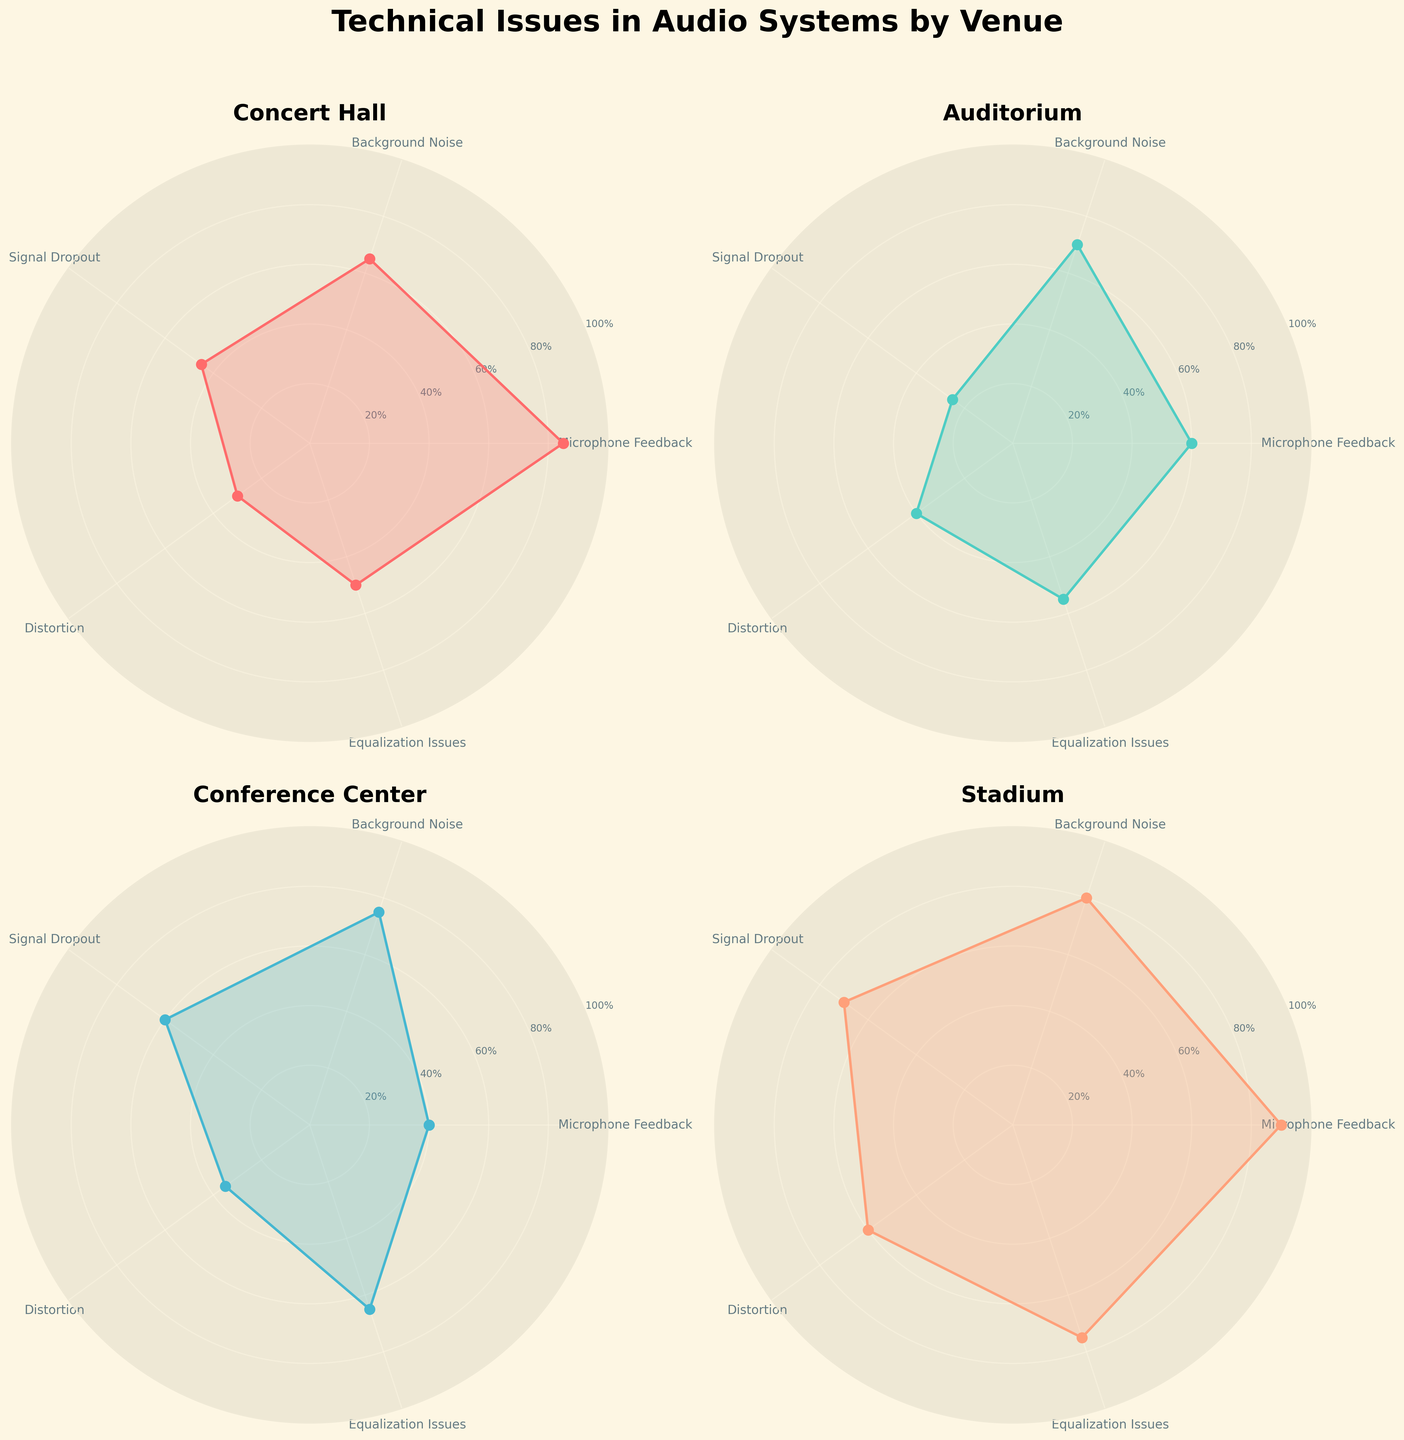What is the most frequent technical issue in Stadiums? Look at the Stadium subplot and identify the highest point on the radar chart. The highest value is for Background Noise at 80.
Answer: Background Noise Which venue reports the highest frequency of Microphone Feedback? Compare the Microphone Feedback frequencies across all four subplots. The highest value is in the Stadium subplot at 90.
Answer: Stadium How does the frequency of Signal Dropout in Conference Centers compare to that in Concert Halls? Find the values for Signal Dropout in both venues. In the Conference Center, it's 60; in the Concert Hall, it's 45.
Answer: Higher in Conference Centers Which technical issue has the lowest frequency in the Auditorium? Identify the lowest point on the radar chart for the Auditorium subplot. The lowest value is for Signal Dropout at 25.
Answer: Signal Dropout What is the average frequency of technical issues in Concert Halls? Sum the frequencies of all issues in Concert Halls and divide by the number of issues. (85 + 65 + 45 + 30 + 50)/5 = 55
Answer: 55 Which venue reports relatively low frequencies for Distortion? Compare the Distortion frequencies across all subplots. The lowest value is in the Conference Center subplot at 35.
Answer: Conference Center Which venue has the closest frequency values for Microphone Feedback and Equalization Issues? Calculate the difference between the frequencies for Microphone Feedback and Equalization Issues in each venue. The smallest difference is in the Auditorium (60 - 55 = 5).
Answer: Auditorium What are the frequencies of Background Noise in all venues? Refer to the subplots and list the frequencies for Background Noise in all venues: Concert Hall (65), Auditorium (70), Conference Center (75), Stadium (80).
Answer: Concert Hall: 65, Auditorium: 70, Conference Center: 75, Stadium: 80 If you average the frequencies of Equalization Issues across all venues, what would the value be? Sum the frequencies of Equalization Issues for all venues and divide by the number of venues. (50 + 55 + 65 + 75)/4 = 61.25
Answer: 61.25 